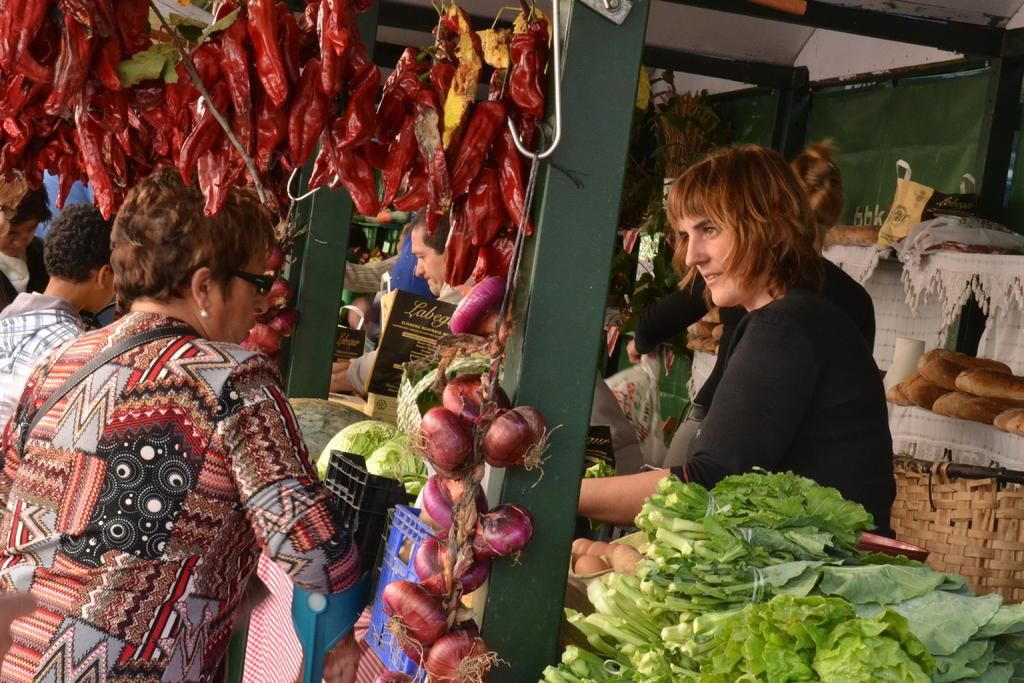What type of establishment is shown in the image? There is a shop in the image. What type of products can be seen in the shop? There are vegetables visible in the shop. Are there any people present in the image? Yes, there are people visible in the shop. How many police officers are visible in the image? There are no police officers present in the image. What type of bottle is being sold in the shop? There is no bottle visible in the image; only vegetables are shown. 